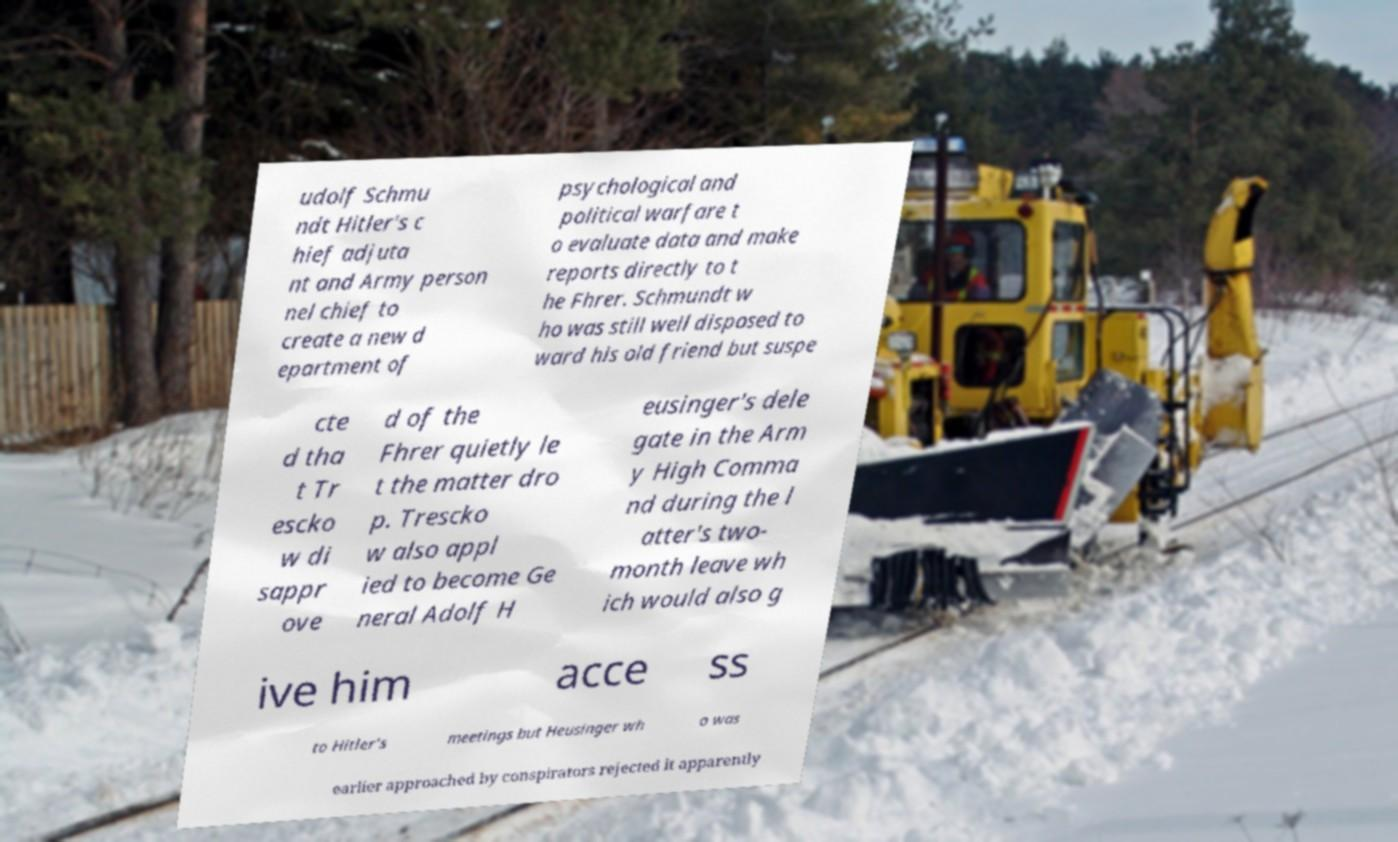Please identify and transcribe the text found in this image. udolf Schmu ndt Hitler's c hief adjuta nt and Army person nel chief to create a new d epartment of psychological and political warfare t o evaluate data and make reports directly to t he Fhrer. Schmundt w ho was still well disposed to ward his old friend but suspe cte d tha t Tr escko w di sappr ove d of the Fhrer quietly le t the matter dro p. Trescko w also appl ied to become Ge neral Adolf H eusinger's dele gate in the Arm y High Comma nd during the l atter's two- month leave wh ich would also g ive him acce ss to Hitler's meetings but Heusinger wh o was earlier approached by conspirators rejected it apparently 